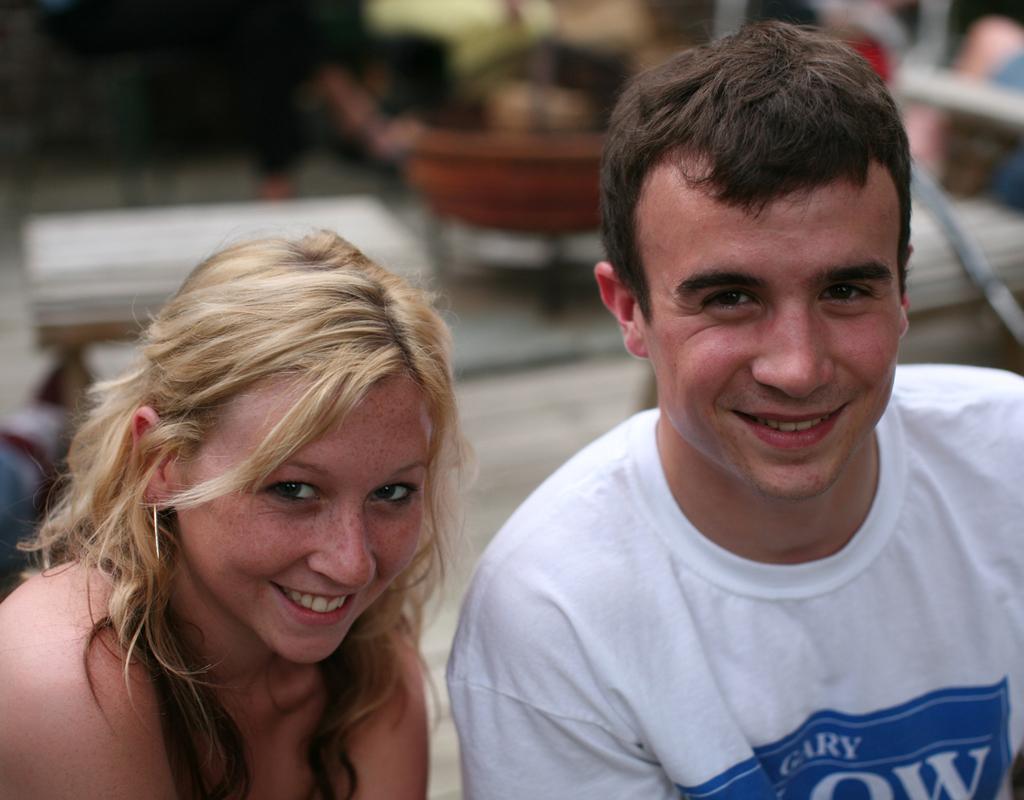Could you give a brief overview of what you see in this image? In this picture we can see two persons,they are smiling and in the background we can see some objects. 